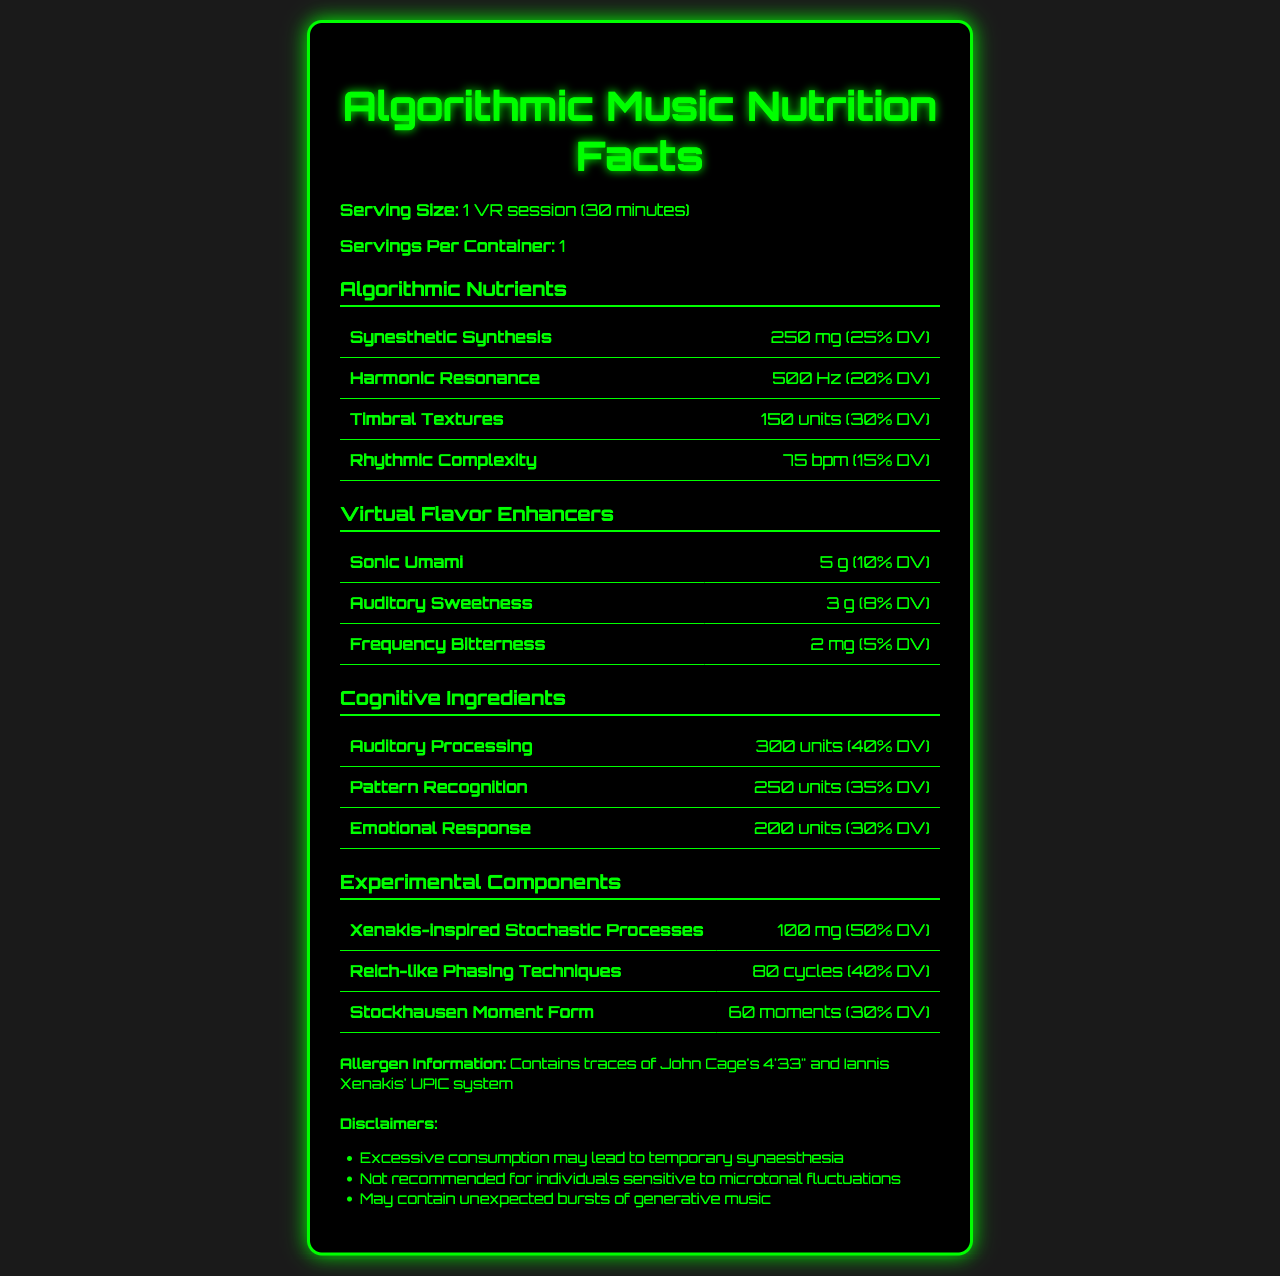What is the serving size for the VR session? The serving size is explicitly listed as "1 VR session (30 minutes)" at the beginning of the document.
Answer: 1 VR session (30 minutes) How many servings are there per container? The number of servings per container is mentioned directly in the document.
Answer: 1 How much Synesthetic Synthesis does the VR session contain? The amount of Synesthetic Synthesis is listed as 250 mg in the Algorithmic Nutrients section.
Answer: 250 mg Provide the daily value percentage of Harmonic Resonance. The document specifies that the daily value percentage of Harmonic Resonance is 20% in the Algorithmic Nutrients section.
Answer: 20% What is the daily value percentage of Auditory Processing? The document states that the daily value percentage of Auditory Processing is 40% in the Cognitive Ingredients section.
Answer: 40% Which of the following is a Virtual Flavor Enhancer? A. Synesthetic Synthesis B. Sonic Umami C. Auditory Processing D. Stockhausen Moment Form Sonic Umami is listed as a Virtual Flavor Enhancer.
Answer: B Identify an Experimental Component from the VR session. A. Synesthetic Synthesis B. Timbral Textures C. Xenakis-inspired Stochastic Processes D. Auditory Sweetness Xenakis-inspired Stochastic Processes is mentioned in the Experimental Components section.
Answer: C Did the document mention any allergens? The allergen information section states that the session contains traces of John Cage's 4'33" and Iannis Xenakis' UPIC system.
Answer: Yes Summarize the nutritional breakdown of the VR Taste Experience document. The overall document details a unique experience showcasing the nutritional values and elements involved in a VR session driven by algorithmic music, including numerous innovative and cognitive components as well as certain allergens and disclaimers.
Answer: The document presents the nutritional breakdown of a 30-minute VR session focused on algorithmic music. It includes sections on serving size, calories, algorithmic nutrients, virtual flavor enhancers, cognitive ingredients, experimental components, allergen information, and disclaimers. The session contains various algorithmic and cognitive elements with no calories or macronutrients. What are the precautions mentioned in the document? These precautions are listed under the disclaimers section.
Answer: Excessive consumption may lead to temporary synaesthesia, not recommended for individuals sensitive to microtonal fluctuations, may contain unexpected bursts of generative music. What percentage of daily value is provided by Timbral Textures? The document mentions a 30% daily value for Timbral Textures in the Algorithmic Nutrients section.
Answer: 30% What flavor enhancer contributes 10% to the daily value? Sonic Umami contributes 10% to the daily value as mentioned in the Virtual Flavor Enhancers section.
Answer: Sonic Umami How many experimental components are mentioned? The document lists three experimental components: Xenakis-inspired Stochastic Processes, Reich-like Phasing Techniques, and Stockhausen Moment Form.
Answer: Three Is "Math-Driven Beats" listed as an ingredient in this document? There is no mention of "Math-Driven Beats" in any section of the document.
Answer: No What is the unit of measurement for Harmonic Resonance? The unit of measurement for Harmonic Resonance is listed as Hz in the Algorithmic Nutrients section.
Answer: Hz What is the recommended duration of a VR session to get the listed nutritional values? The serving size is defined as "1 VR session (30 minutes)" which indicates the duration.
Answer: 30 minutes 